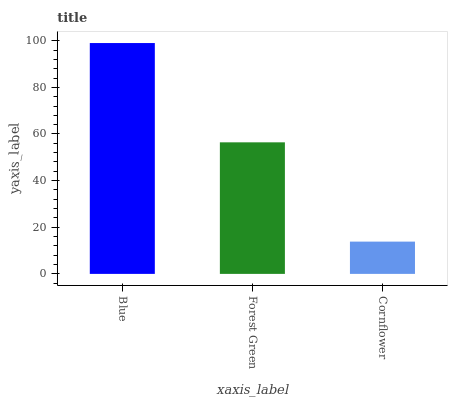Is Cornflower the minimum?
Answer yes or no. Yes. Is Blue the maximum?
Answer yes or no. Yes. Is Forest Green the minimum?
Answer yes or no. No. Is Forest Green the maximum?
Answer yes or no. No. Is Blue greater than Forest Green?
Answer yes or no. Yes. Is Forest Green less than Blue?
Answer yes or no. Yes. Is Forest Green greater than Blue?
Answer yes or no. No. Is Blue less than Forest Green?
Answer yes or no. No. Is Forest Green the high median?
Answer yes or no. Yes. Is Forest Green the low median?
Answer yes or no. Yes. Is Cornflower the high median?
Answer yes or no. No. Is Blue the low median?
Answer yes or no. No. 